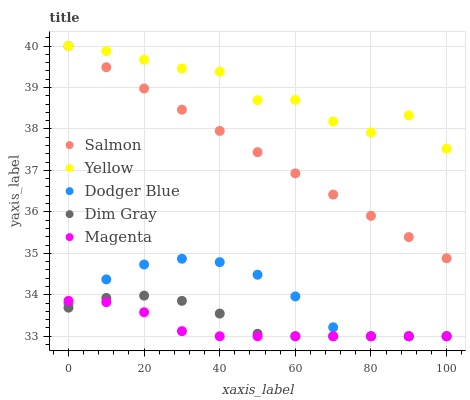Does Magenta have the minimum area under the curve?
Answer yes or no. Yes. Does Yellow have the maximum area under the curve?
Answer yes or no. Yes. Does Dim Gray have the minimum area under the curve?
Answer yes or no. No. Does Dim Gray have the maximum area under the curve?
Answer yes or no. No. Is Salmon the smoothest?
Answer yes or no. Yes. Is Yellow the roughest?
Answer yes or no. Yes. Is Magenta the smoothest?
Answer yes or no. No. Is Magenta the roughest?
Answer yes or no. No. Does Dodger Blue have the lowest value?
Answer yes or no. Yes. Does Salmon have the lowest value?
Answer yes or no. No. Does Yellow have the highest value?
Answer yes or no. Yes. Does Dim Gray have the highest value?
Answer yes or no. No. Is Dim Gray less than Yellow?
Answer yes or no. Yes. Is Salmon greater than Magenta?
Answer yes or no. Yes. Does Dodger Blue intersect Dim Gray?
Answer yes or no. Yes. Is Dodger Blue less than Dim Gray?
Answer yes or no. No. Is Dodger Blue greater than Dim Gray?
Answer yes or no. No. Does Dim Gray intersect Yellow?
Answer yes or no. No. 